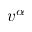Convert formula to latex. <formula><loc_0><loc_0><loc_500><loc_500>v ^ { \alpha }</formula> 